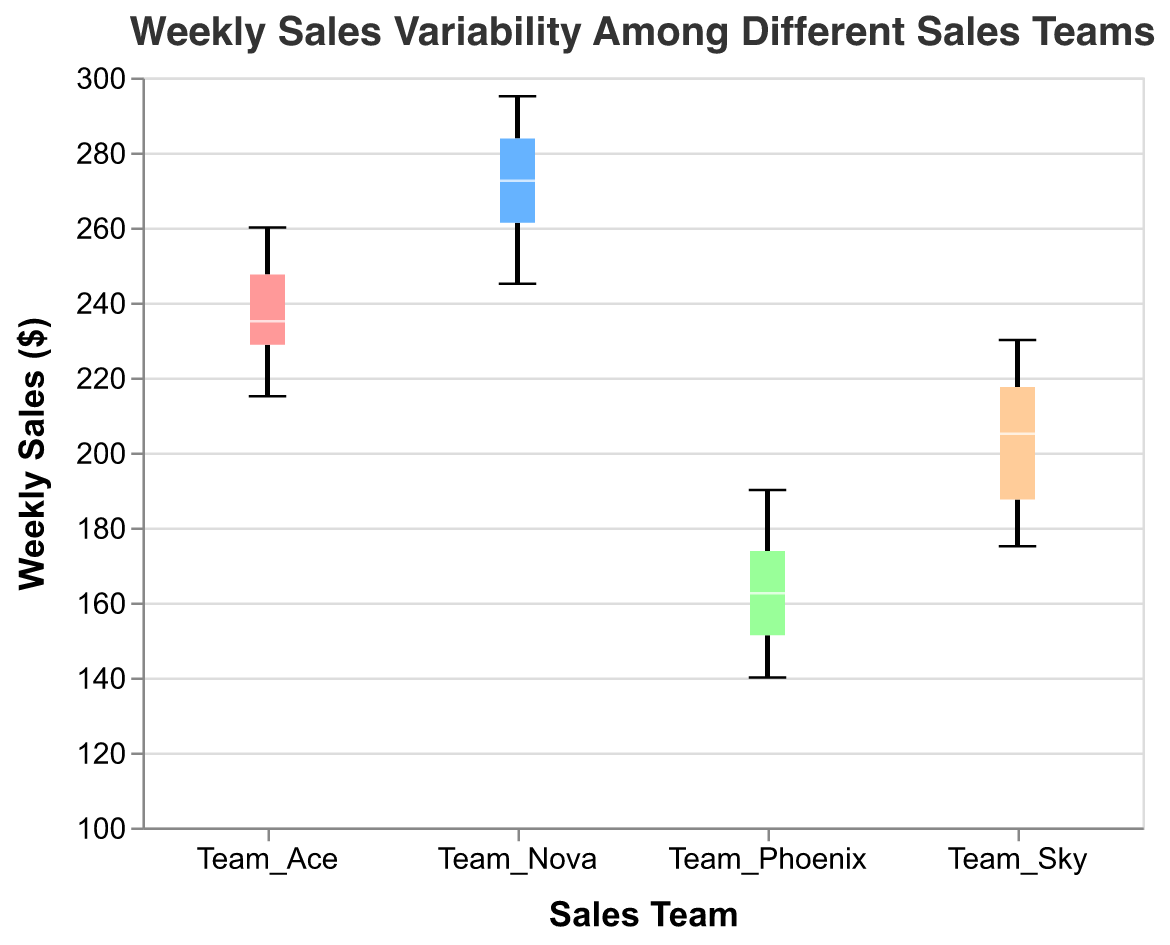What is the title of the figure? The title is mentioned at the top of the figure. It is "Weekly Sales Variability Among Different Sales Teams"
Answer: Weekly Sales Variability Among Different Sales Teams Which sales team has the widest range of weekly sales? By looking at the vertical extent from the minimum to the maximum value within each box plot, we can see which team has the widest range. Team Sky has noticeable variability, but Team Nova's range is wider, spanning from nearly 245 to 295.
Answer: Team Nova What is the median weekly sales for Team Ace? The median is represented by a line within the box. For Team Ace, this median line is at 235.
Answer: 235 Which sales team has the least variability in weekly sales? The least variability is determined by the shortest vertical extent of the box plot, excluding any outliers. Team Phoenix has the least range, from around 140 to 190.
Answer: Team Phoenix Does any sales team have outliers? Outliers are usually indicated by individual points outside the whiskers of the box plot. No sales team box plot shows individual data points outside the whiskers, suggesting no outliers.
Answer: No Which team has the highest median weekly sales? The median is the line inside the box. Team Nova has the highest median weekly sales because its median line is the highest among all the teams.
Answer: Team Nova Compare the interquartile range (IQR) of Team Ace and Team Sky. Which team has a larger IQR? The IQR is represented by the height of the box itself (from Q1 to Q3). Comparing the height of the boxes visually, Team Ace has a larger interquartile range than Team Sky.
Answer: Team Ace How does Team Phoenix’s performance compare to Team Nova in terms of weekly sales? Team Phoenix has lower weekly sales overall compared to Team Nova. Team Nova's range starts at the top of Team Phoenix's range and extends much higher. Team Nova's box plot is fully above Team Phoenix's, suggesting consistently higher sales.
Answer: Team Nova performs better What’s the minimum weekly sales value for Team Sky? The minimum value of weekly sales for Team Sky is indicated by the bottom whisker of the box plot for Team Sky. This value is around 175.
Answer: 175 What does the notch in the box plot represent and suggest about the medians of Team Ace and Team Nova? The notch in the box plot represents the 95% confidence interval around the median. If the notches of two boxes do not overlap, it suggests a statistically significant difference between the medians. Since the notches for Team Ace and Team Nova do not overlap, their medians are significantly different.
Answer: Statistically significant difference 